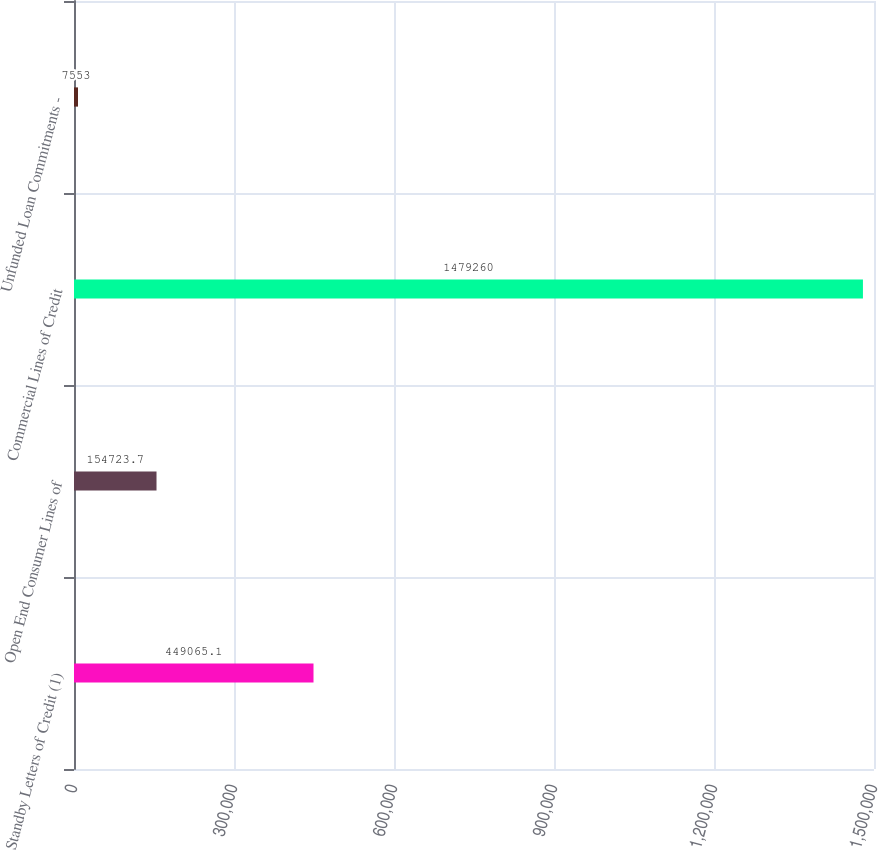Convert chart to OTSL. <chart><loc_0><loc_0><loc_500><loc_500><bar_chart><fcel>Standby Letters of Credit (1)<fcel>Open End Consumer Lines of<fcel>Commercial Lines of Credit<fcel>Unfunded Loan Commitments -<nl><fcel>449065<fcel>154724<fcel>1.47926e+06<fcel>7553<nl></chart> 